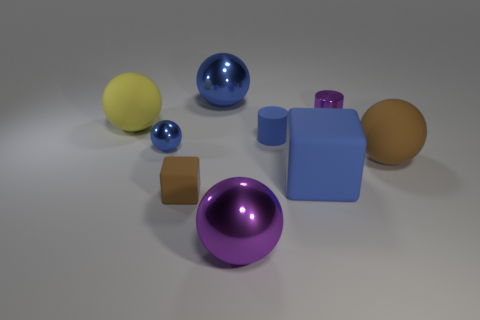Is the number of small blue cylinders behind the tiny purple metal cylinder less than the number of large purple metal objects left of the brown matte cube?
Your response must be concise. No. Is there a big rubber block that has the same color as the tiny rubber cylinder?
Keep it short and to the point. Yes. Do the brown cube and the big brown object that is behind the small brown rubber block have the same material?
Make the answer very short. Yes. Is there a shiny ball in front of the blue matte thing right of the small blue cylinder?
Offer a terse response. Yes. There is a large thing that is both in front of the large brown rubber ball and behind the big purple object; what color is it?
Provide a short and direct response. Blue. The brown matte cube has what size?
Your answer should be very brief. Small. What number of gray matte balls are the same size as the brown ball?
Offer a very short reply. 0. Is the cube that is on the right side of the big purple sphere made of the same material as the large ball that is right of the tiny purple thing?
Your response must be concise. Yes. There is a large blue object in front of the rubber ball that is in front of the blue cylinder; what is its material?
Provide a short and direct response. Rubber. There is a blue object to the left of the tiny matte cube; what is it made of?
Make the answer very short. Metal. 